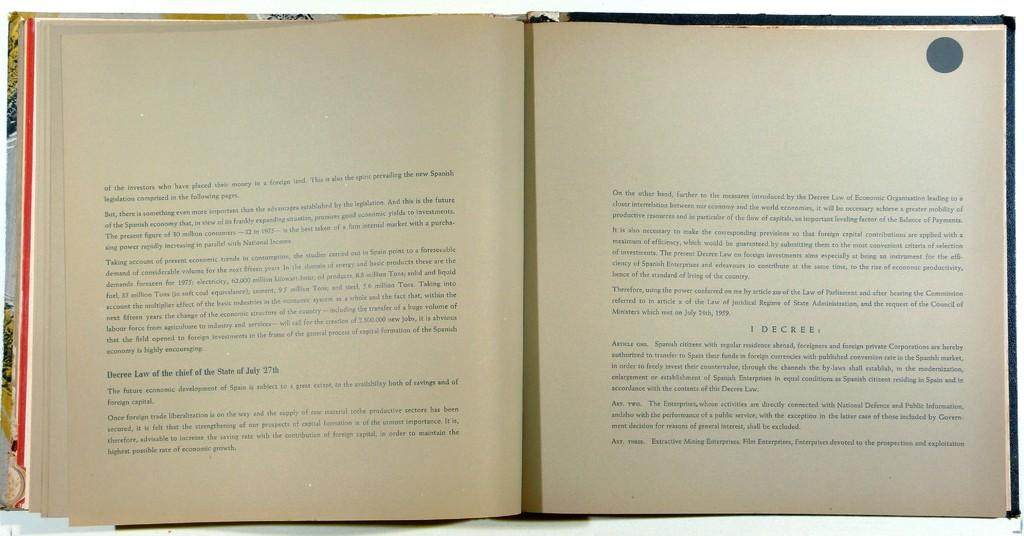Provide a one-sentence caption for the provided image. An open book that begins talking about the investors. 